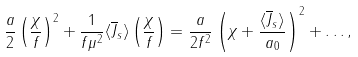<formula> <loc_0><loc_0><loc_500><loc_500>\frac { a } { 2 } \left ( \frac { \chi } { f } \right ) ^ { 2 } + \frac { 1 } { f { \mu } ^ { 2 } } \langle \overline { J } _ { s } \rangle \left ( \frac { \chi } { f } \right ) = \frac { a } { 2 f ^ { 2 } } \left ( { \chi } + \frac { \langle \overline { J } _ { s } \rangle } { a _ { 0 } } \right ) ^ { 2 } + \dots ,</formula> 